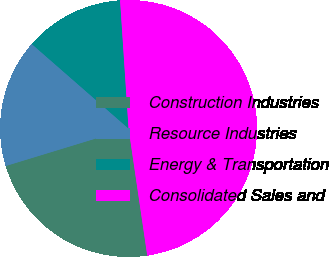Convert chart. <chart><loc_0><loc_0><loc_500><loc_500><pie_chart><fcel>Construction Industries<fcel>Resource Industries<fcel>Energy & Transportation<fcel>Consolidated Sales and<nl><fcel>22.61%<fcel>16.14%<fcel>12.52%<fcel>48.72%<nl></chart> 